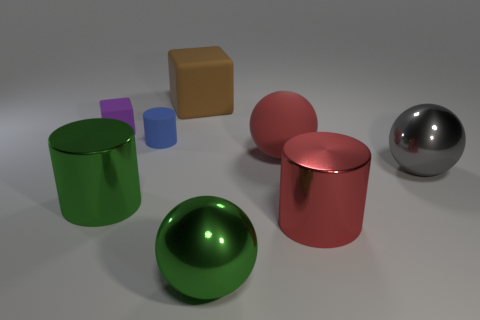Subtract all large red cylinders. How many cylinders are left? 2 Subtract all red cylinders. How many cylinders are left? 2 Subtract 1 spheres. How many spheres are left? 2 Add 2 green metal things. How many objects exist? 10 Subtract all cylinders. How many objects are left? 5 Subtract all brown cylinders. Subtract all blue blocks. How many cylinders are left? 3 Subtract all cyan blocks. How many green cylinders are left? 1 Subtract all small green cylinders. Subtract all small matte cylinders. How many objects are left? 7 Add 4 big gray metallic objects. How many big gray metallic objects are left? 5 Add 3 big green objects. How many big green objects exist? 5 